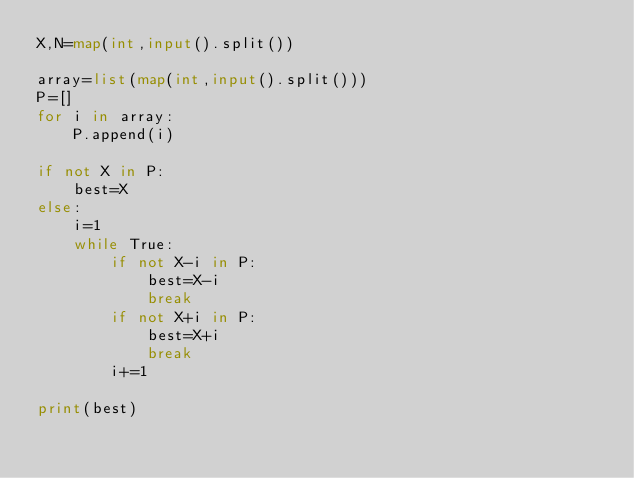<code> <loc_0><loc_0><loc_500><loc_500><_Python_>X,N=map(int,input().split())

array=list(map(int,input().split()))
P=[]
for i in array:
    P.append(i)

if not X in P:
    best=X
else:
    i=1
    while True:
        if not X-i in P:
            best=X-i
            break
        if not X+i in P:
            best=X+i
            break
        i+=1

print(best)
</code> 